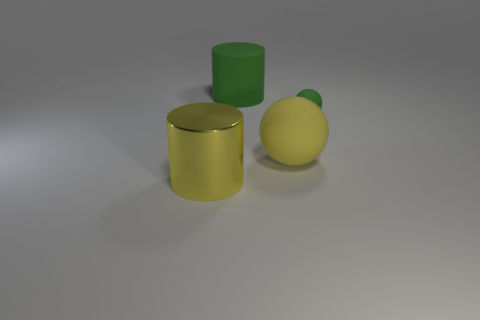Subtract all brown cylinders. Subtract all blue blocks. How many cylinders are left? 2 Add 2 large yellow matte spheres. How many objects exist? 6 Add 3 green cylinders. How many green cylinders are left? 4 Add 3 large objects. How many large objects exist? 6 Subtract 0 gray balls. How many objects are left? 4 Subtract all big shiny cylinders. Subtract all matte cylinders. How many objects are left? 2 